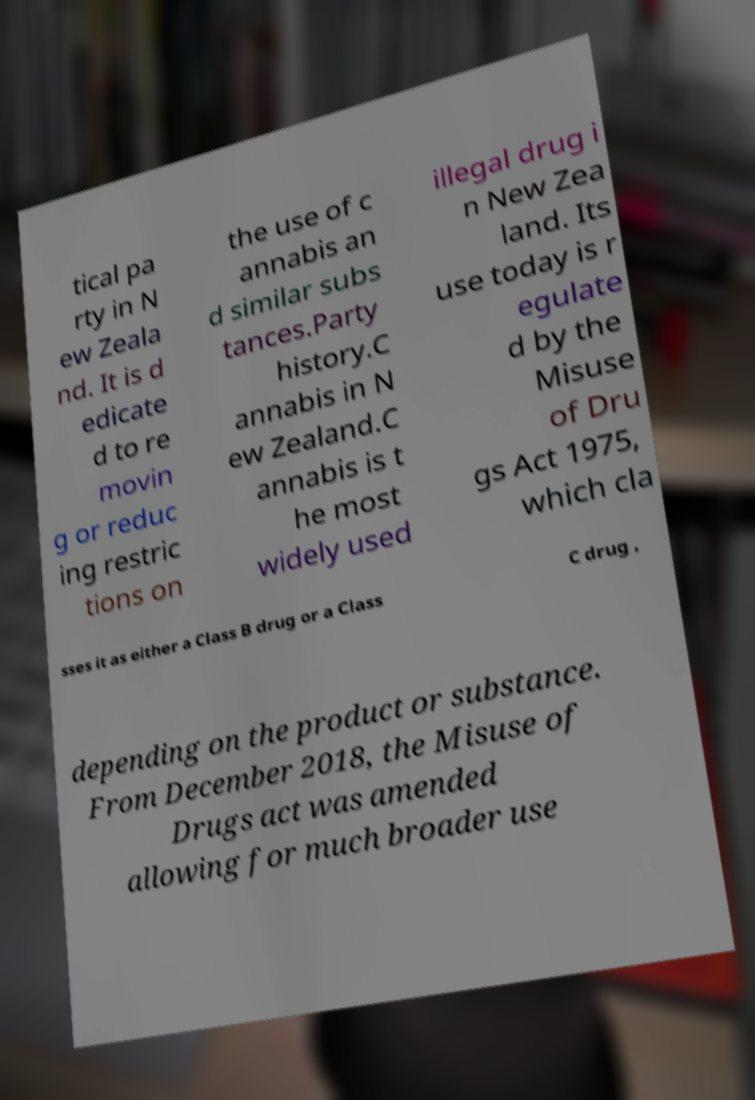Can you read and provide the text displayed in the image?This photo seems to have some interesting text. Can you extract and type it out for me? tical pa rty in N ew Zeala nd. It is d edicate d to re movin g or reduc ing restric tions on the use of c annabis an d similar subs tances.Party history.C annabis in N ew Zealand.C annabis is t he most widely used illegal drug i n New Zea land. Its use today is r egulate d by the Misuse of Dru gs Act 1975, which cla sses it as either a Class B drug or a Class C drug , depending on the product or substance. From December 2018, the Misuse of Drugs act was amended allowing for much broader use 